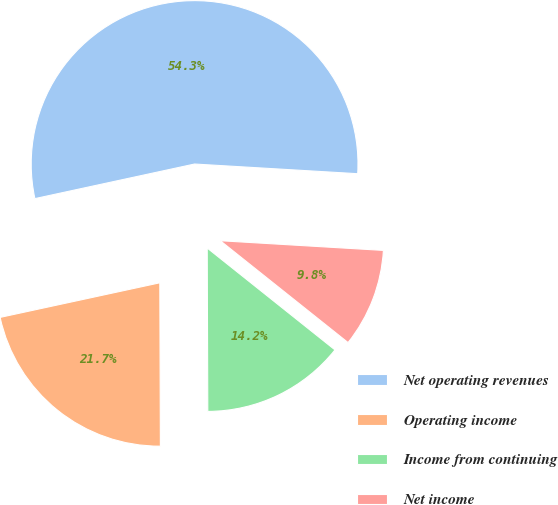<chart> <loc_0><loc_0><loc_500><loc_500><pie_chart><fcel>Net operating revenues<fcel>Operating income<fcel>Income from continuing<fcel>Net income<nl><fcel>54.34%<fcel>21.66%<fcel>14.23%<fcel>9.77%<nl></chart> 